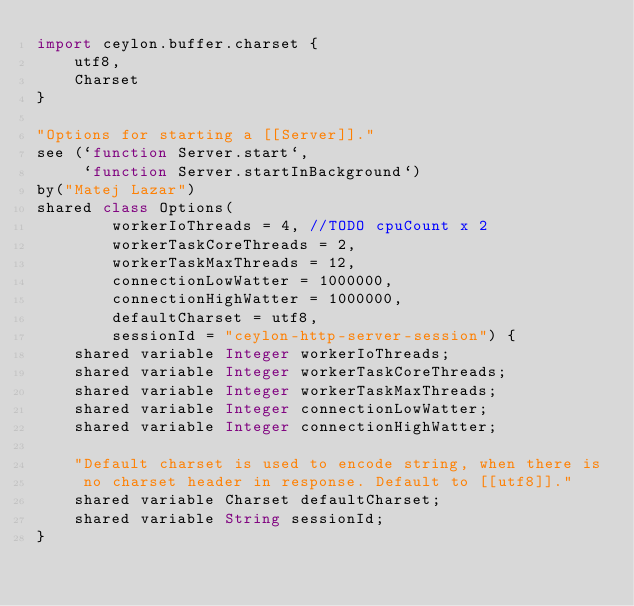<code> <loc_0><loc_0><loc_500><loc_500><_Ceylon_>import ceylon.buffer.charset {
    utf8,
    Charset
}

"Options for starting a [[Server]]."
see (`function Server.start`, 
     `function Server.startInBackground`)
by("Matej Lazar")
shared class Options(
        workerIoThreads = 4, //TODO cpuCount x 2
        workerTaskCoreThreads = 2, 
        workerTaskMaxThreads = 12,
        connectionLowWatter = 1000000,
        connectionHighWatter = 1000000,
        defaultCharset = utf8,
        sessionId = "ceylon-http-server-session") {
    shared variable Integer workerIoThreads;
    shared variable Integer workerTaskCoreThreads;
    shared variable Integer workerTaskMaxThreads;
    shared variable Integer connectionLowWatter;
    shared variable Integer connectionHighWatter;
    
    "Default charset is used to encode string, when there is 
     no charset header in response. Default to [[utf8]]."
    shared variable Charset defaultCharset;
    shared variable String sessionId;
}
</code> 